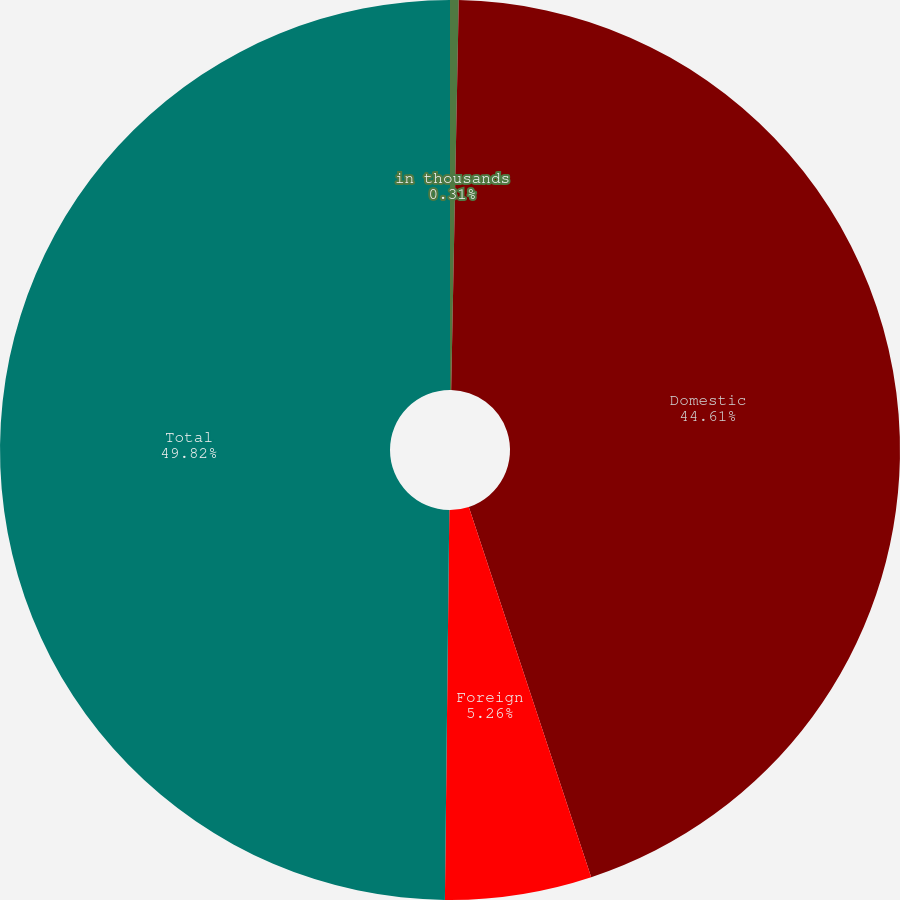<chart> <loc_0><loc_0><loc_500><loc_500><pie_chart><fcel>in thousands<fcel>Domestic<fcel>Foreign<fcel>Total<nl><fcel>0.31%<fcel>44.61%<fcel>5.26%<fcel>49.82%<nl></chart> 